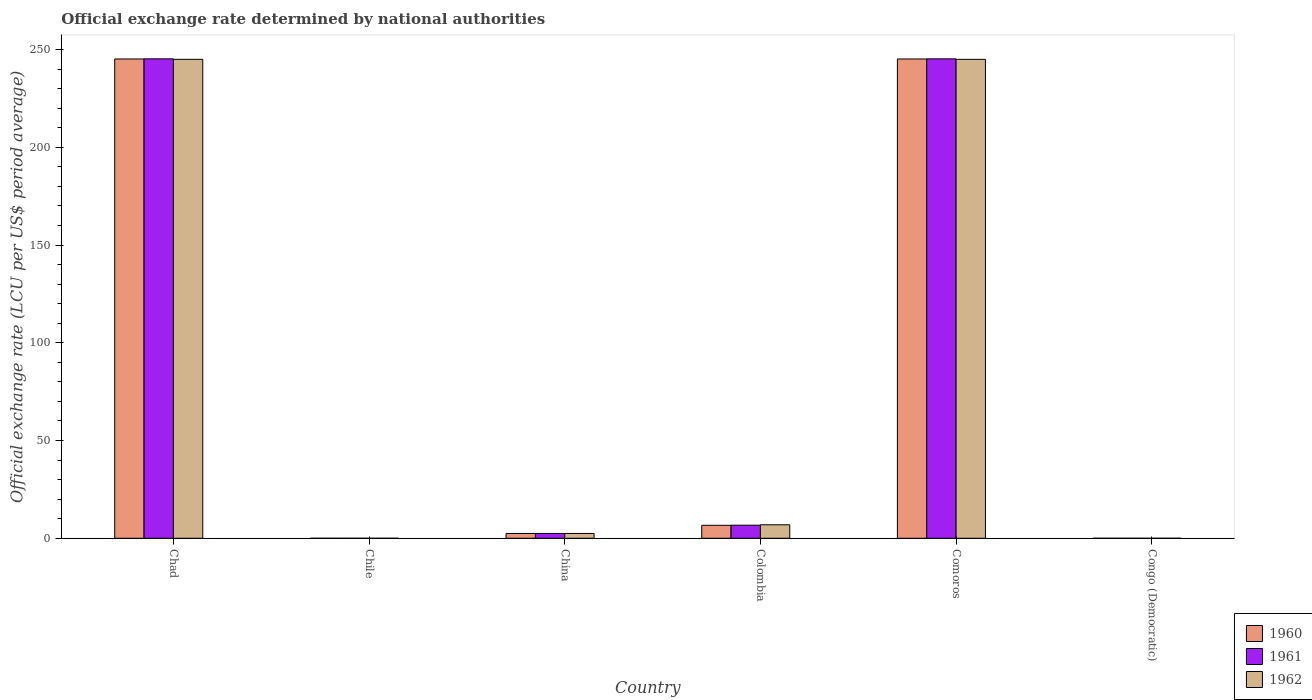How many groups of bars are there?
Your answer should be very brief. 6. Are the number of bars per tick equal to the number of legend labels?
Keep it short and to the point. Yes. What is the official exchange rate in 1961 in Chad?
Ensure brevity in your answer.  245.26. Across all countries, what is the maximum official exchange rate in 1961?
Give a very brief answer. 245.26. Across all countries, what is the minimum official exchange rate in 1961?
Make the answer very short. 1.75e-13. In which country was the official exchange rate in 1961 maximum?
Make the answer very short. Chad. In which country was the official exchange rate in 1961 minimum?
Offer a very short reply. Congo (Democratic). What is the total official exchange rate in 1962 in the graph?
Your answer should be very brief. 499.39. What is the difference between the official exchange rate in 1962 in Chile and that in Colombia?
Your answer should be very brief. -6.9. What is the difference between the official exchange rate in 1962 in China and the official exchange rate in 1961 in Chad?
Provide a succinct answer. -242.8. What is the average official exchange rate in 1962 per country?
Provide a succinct answer. 83.23. What is the difference between the official exchange rate of/in 1960 and official exchange rate of/in 1962 in Chad?
Your answer should be very brief. 0.18. What is the ratio of the official exchange rate in 1960 in Chad to that in China?
Offer a terse response. 99.6. What is the difference between the highest and the second highest official exchange rate in 1960?
Provide a short and direct response. -0. What is the difference between the highest and the lowest official exchange rate in 1961?
Make the answer very short. 245.26. In how many countries, is the official exchange rate in 1961 greater than the average official exchange rate in 1961 taken over all countries?
Ensure brevity in your answer.  2. Is the sum of the official exchange rate in 1961 in Chad and Comoros greater than the maximum official exchange rate in 1960 across all countries?
Your answer should be compact. Yes. What does the 3rd bar from the right in Chad represents?
Provide a short and direct response. 1960. Are all the bars in the graph horizontal?
Provide a short and direct response. No. How many countries are there in the graph?
Your response must be concise. 6. Are the values on the major ticks of Y-axis written in scientific E-notation?
Offer a terse response. No. Does the graph contain grids?
Keep it short and to the point. No. Where does the legend appear in the graph?
Provide a succinct answer. Bottom right. How many legend labels are there?
Ensure brevity in your answer.  3. What is the title of the graph?
Ensure brevity in your answer.  Official exchange rate determined by national authorities. What is the label or title of the X-axis?
Offer a very short reply. Country. What is the label or title of the Y-axis?
Give a very brief answer. Official exchange rate (LCU per US$ period average). What is the Official exchange rate (LCU per US$ period average) in 1960 in Chad?
Ensure brevity in your answer.  245.2. What is the Official exchange rate (LCU per US$ period average) in 1961 in Chad?
Give a very brief answer. 245.26. What is the Official exchange rate (LCU per US$ period average) of 1962 in Chad?
Give a very brief answer. 245.01. What is the Official exchange rate (LCU per US$ period average) in 1960 in Chile?
Your response must be concise. 0. What is the Official exchange rate (LCU per US$ period average) in 1961 in Chile?
Your response must be concise. 0. What is the Official exchange rate (LCU per US$ period average) of 1962 in Chile?
Offer a very short reply. 0. What is the Official exchange rate (LCU per US$ period average) in 1960 in China?
Offer a terse response. 2.46. What is the Official exchange rate (LCU per US$ period average) in 1961 in China?
Offer a terse response. 2.46. What is the Official exchange rate (LCU per US$ period average) in 1962 in China?
Your response must be concise. 2.46. What is the Official exchange rate (LCU per US$ period average) in 1960 in Colombia?
Your response must be concise. 6.63. What is the Official exchange rate (LCU per US$ period average) in 1961 in Colombia?
Ensure brevity in your answer.  6.7. What is the Official exchange rate (LCU per US$ period average) in 1962 in Colombia?
Provide a succinct answer. 6.9. What is the Official exchange rate (LCU per US$ period average) of 1960 in Comoros?
Make the answer very short. 245.19. What is the Official exchange rate (LCU per US$ period average) in 1961 in Comoros?
Your response must be concise. 245.26. What is the Official exchange rate (LCU per US$ period average) of 1962 in Comoros?
Ensure brevity in your answer.  245.01. What is the Official exchange rate (LCU per US$ period average) of 1960 in Congo (Democratic)?
Your response must be concise. 1.7e-13. What is the Official exchange rate (LCU per US$ period average) of 1961 in Congo (Democratic)?
Offer a terse response. 1.75e-13. What is the Official exchange rate (LCU per US$ period average) of 1962 in Congo (Democratic)?
Offer a terse response. 2.1e-13. Across all countries, what is the maximum Official exchange rate (LCU per US$ period average) in 1960?
Keep it short and to the point. 245.2. Across all countries, what is the maximum Official exchange rate (LCU per US$ period average) in 1961?
Offer a terse response. 245.26. Across all countries, what is the maximum Official exchange rate (LCU per US$ period average) in 1962?
Your response must be concise. 245.01. Across all countries, what is the minimum Official exchange rate (LCU per US$ period average) of 1960?
Keep it short and to the point. 1.7e-13. Across all countries, what is the minimum Official exchange rate (LCU per US$ period average) in 1961?
Your response must be concise. 1.75e-13. Across all countries, what is the minimum Official exchange rate (LCU per US$ period average) in 1962?
Your answer should be very brief. 2.1e-13. What is the total Official exchange rate (LCU per US$ period average) in 1960 in the graph?
Your answer should be very brief. 499.49. What is the total Official exchange rate (LCU per US$ period average) of 1961 in the graph?
Your answer should be compact. 499.68. What is the total Official exchange rate (LCU per US$ period average) in 1962 in the graph?
Offer a very short reply. 499.39. What is the difference between the Official exchange rate (LCU per US$ period average) in 1960 in Chad and that in Chile?
Make the answer very short. 245.19. What is the difference between the Official exchange rate (LCU per US$ period average) of 1961 in Chad and that in Chile?
Keep it short and to the point. 245.26. What is the difference between the Official exchange rate (LCU per US$ period average) in 1962 in Chad and that in Chile?
Ensure brevity in your answer.  245.01. What is the difference between the Official exchange rate (LCU per US$ period average) in 1960 in Chad and that in China?
Your response must be concise. 242.73. What is the difference between the Official exchange rate (LCU per US$ period average) in 1961 in Chad and that in China?
Your response must be concise. 242.8. What is the difference between the Official exchange rate (LCU per US$ period average) of 1962 in Chad and that in China?
Your answer should be very brief. 242.55. What is the difference between the Official exchange rate (LCU per US$ period average) in 1960 in Chad and that in Colombia?
Offer a terse response. 238.56. What is the difference between the Official exchange rate (LCU per US$ period average) of 1961 in Chad and that in Colombia?
Your answer should be very brief. 238.56. What is the difference between the Official exchange rate (LCU per US$ period average) of 1962 in Chad and that in Colombia?
Your answer should be very brief. 238.11. What is the difference between the Official exchange rate (LCU per US$ period average) in 1960 in Chad and that in Comoros?
Provide a succinct answer. 0. What is the difference between the Official exchange rate (LCU per US$ period average) of 1961 in Chad and that in Comoros?
Keep it short and to the point. 0. What is the difference between the Official exchange rate (LCU per US$ period average) in 1962 in Chad and that in Comoros?
Your answer should be very brief. 0. What is the difference between the Official exchange rate (LCU per US$ period average) of 1960 in Chad and that in Congo (Democratic)?
Your response must be concise. 245.2. What is the difference between the Official exchange rate (LCU per US$ period average) in 1961 in Chad and that in Congo (Democratic)?
Keep it short and to the point. 245.26. What is the difference between the Official exchange rate (LCU per US$ period average) of 1962 in Chad and that in Congo (Democratic)?
Provide a succinct answer. 245.01. What is the difference between the Official exchange rate (LCU per US$ period average) in 1960 in Chile and that in China?
Make the answer very short. -2.46. What is the difference between the Official exchange rate (LCU per US$ period average) of 1961 in Chile and that in China?
Offer a very short reply. -2.46. What is the difference between the Official exchange rate (LCU per US$ period average) of 1962 in Chile and that in China?
Make the answer very short. -2.46. What is the difference between the Official exchange rate (LCU per US$ period average) of 1960 in Chile and that in Colombia?
Your answer should be very brief. -6.63. What is the difference between the Official exchange rate (LCU per US$ period average) of 1961 in Chile and that in Colombia?
Your response must be concise. -6.7. What is the difference between the Official exchange rate (LCU per US$ period average) of 1962 in Chile and that in Colombia?
Provide a short and direct response. -6.9. What is the difference between the Official exchange rate (LCU per US$ period average) in 1960 in Chile and that in Comoros?
Your response must be concise. -245.19. What is the difference between the Official exchange rate (LCU per US$ period average) in 1961 in Chile and that in Comoros?
Provide a short and direct response. -245.26. What is the difference between the Official exchange rate (LCU per US$ period average) in 1962 in Chile and that in Comoros?
Offer a terse response. -245.01. What is the difference between the Official exchange rate (LCU per US$ period average) of 1960 in Chile and that in Congo (Democratic)?
Offer a very short reply. 0. What is the difference between the Official exchange rate (LCU per US$ period average) of 1961 in Chile and that in Congo (Democratic)?
Provide a short and direct response. 0. What is the difference between the Official exchange rate (LCU per US$ period average) of 1962 in Chile and that in Congo (Democratic)?
Your answer should be compact. 0. What is the difference between the Official exchange rate (LCU per US$ period average) in 1960 in China and that in Colombia?
Provide a succinct answer. -4.17. What is the difference between the Official exchange rate (LCU per US$ period average) in 1961 in China and that in Colombia?
Offer a very short reply. -4.24. What is the difference between the Official exchange rate (LCU per US$ period average) of 1962 in China and that in Colombia?
Your answer should be very brief. -4.44. What is the difference between the Official exchange rate (LCU per US$ period average) of 1960 in China and that in Comoros?
Your answer should be very brief. -242.73. What is the difference between the Official exchange rate (LCU per US$ period average) of 1961 in China and that in Comoros?
Ensure brevity in your answer.  -242.8. What is the difference between the Official exchange rate (LCU per US$ period average) of 1962 in China and that in Comoros?
Offer a very short reply. -242.55. What is the difference between the Official exchange rate (LCU per US$ period average) in 1960 in China and that in Congo (Democratic)?
Offer a terse response. 2.46. What is the difference between the Official exchange rate (LCU per US$ period average) in 1961 in China and that in Congo (Democratic)?
Provide a short and direct response. 2.46. What is the difference between the Official exchange rate (LCU per US$ period average) in 1962 in China and that in Congo (Democratic)?
Your response must be concise. 2.46. What is the difference between the Official exchange rate (LCU per US$ period average) of 1960 in Colombia and that in Comoros?
Give a very brief answer. -238.56. What is the difference between the Official exchange rate (LCU per US$ period average) in 1961 in Colombia and that in Comoros?
Your answer should be compact. -238.56. What is the difference between the Official exchange rate (LCU per US$ period average) of 1962 in Colombia and that in Comoros?
Give a very brief answer. -238.11. What is the difference between the Official exchange rate (LCU per US$ period average) in 1960 in Colombia and that in Congo (Democratic)?
Your response must be concise. 6.63. What is the difference between the Official exchange rate (LCU per US$ period average) in 1962 in Colombia and that in Congo (Democratic)?
Make the answer very short. 6.9. What is the difference between the Official exchange rate (LCU per US$ period average) of 1960 in Comoros and that in Congo (Democratic)?
Offer a very short reply. 245.19. What is the difference between the Official exchange rate (LCU per US$ period average) in 1961 in Comoros and that in Congo (Democratic)?
Your answer should be compact. 245.26. What is the difference between the Official exchange rate (LCU per US$ period average) in 1962 in Comoros and that in Congo (Democratic)?
Offer a terse response. 245.01. What is the difference between the Official exchange rate (LCU per US$ period average) of 1960 in Chad and the Official exchange rate (LCU per US$ period average) of 1961 in Chile?
Offer a terse response. 245.19. What is the difference between the Official exchange rate (LCU per US$ period average) in 1960 in Chad and the Official exchange rate (LCU per US$ period average) in 1962 in Chile?
Your answer should be very brief. 245.19. What is the difference between the Official exchange rate (LCU per US$ period average) of 1961 in Chad and the Official exchange rate (LCU per US$ period average) of 1962 in Chile?
Your answer should be very brief. 245.26. What is the difference between the Official exchange rate (LCU per US$ period average) in 1960 in Chad and the Official exchange rate (LCU per US$ period average) in 1961 in China?
Your response must be concise. 242.73. What is the difference between the Official exchange rate (LCU per US$ period average) of 1960 in Chad and the Official exchange rate (LCU per US$ period average) of 1962 in China?
Ensure brevity in your answer.  242.73. What is the difference between the Official exchange rate (LCU per US$ period average) of 1961 in Chad and the Official exchange rate (LCU per US$ period average) of 1962 in China?
Offer a terse response. 242.8. What is the difference between the Official exchange rate (LCU per US$ period average) in 1960 in Chad and the Official exchange rate (LCU per US$ period average) in 1961 in Colombia?
Make the answer very short. 238.5. What is the difference between the Official exchange rate (LCU per US$ period average) of 1960 in Chad and the Official exchange rate (LCU per US$ period average) of 1962 in Colombia?
Keep it short and to the point. 238.29. What is the difference between the Official exchange rate (LCU per US$ period average) in 1961 in Chad and the Official exchange rate (LCU per US$ period average) in 1962 in Colombia?
Ensure brevity in your answer.  238.36. What is the difference between the Official exchange rate (LCU per US$ period average) in 1960 in Chad and the Official exchange rate (LCU per US$ period average) in 1961 in Comoros?
Provide a succinct answer. -0.06. What is the difference between the Official exchange rate (LCU per US$ period average) of 1960 in Chad and the Official exchange rate (LCU per US$ period average) of 1962 in Comoros?
Make the answer very short. 0.18. What is the difference between the Official exchange rate (LCU per US$ period average) in 1961 in Chad and the Official exchange rate (LCU per US$ period average) in 1962 in Comoros?
Keep it short and to the point. 0.25. What is the difference between the Official exchange rate (LCU per US$ period average) in 1960 in Chad and the Official exchange rate (LCU per US$ period average) in 1961 in Congo (Democratic)?
Your response must be concise. 245.2. What is the difference between the Official exchange rate (LCU per US$ period average) of 1960 in Chad and the Official exchange rate (LCU per US$ period average) of 1962 in Congo (Democratic)?
Provide a short and direct response. 245.2. What is the difference between the Official exchange rate (LCU per US$ period average) of 1961 in Chad and the Official exchange rate (LCU per US$ period average) of 1962 in Congo (Democratic)?
Your answer should be very brief. 245.26. What is the difference between the Official exchange rate (LCU per US$ period average) in 1960 in Chile and the Official exchange rate (LCU per US$ period average) in 1961 in China?
Your answer should be compact. -2.46. What is the difference between the Official exchange rate (LCU per US$ period average) in 1960 in Chile and the Official exchange rate (LCU per US$ period average) in 1962 in China?
Your answer should be compact. -2.46. What is the difference between the Official exchange rate (LCU per US$ period average) of 1961 in Chile and the Official exchange rate (LCU per US$ period average) of 1962 in China?
Offer a terse response. -2.46. What is the difference between the Official exchange rate (LCU per US$ period average) in 1960 in Chile and the Official exchange rate (LCU per US$ period average) in 1961 in Colombia?
Your response must be concise. -6.7. What is the difference between the Official exchange rate (LCU per US$ period average) in 1960 in Chile and the Official exchange rate (LCU per US$ period average) in 1962 in Colombia?
Give a very brief answer. -6.9. What is the difference between the Official exchange rate (LCU per US$ period average) of 1961 in Chile and the Official exchange rate (LCU per US$ period average) of 1962 in Colombia?
Keep it short and to the point. -6.9. What is the difference between the Official exchange rate (LCU per US$ period average) in 1960 in Chile and the Official exchange rate (LCU per US$ period average) in 1961 in Comoros?
Give a very brief answer. -245.26. What is the difference between the Official exchange rate (LCU per US$ period average) in 1960 in Chile and the Official exchange rate (LCU per US$ period average) in 1962 in Comoros?
Your response must be concise. -245.01. What is the difference between the Official exchange rate (LCU per US$ period average) in 1961 in Chile and the Official exchange rate (LCU per US$ period average) in 1962 in Comoros?
Offer a terse response. -245.01. What is the difference between the Official exchange rate (LCU per US$ period average) in 1960 in Chile and the Official exchange rate (LCU per US$ period average) in 1962 in Congo (Democratic)?
Your answer should be very brief. 0. What is the difference between the Official exchange rate (LCU per US$ period average) in 1961 in Chile and the Official exchange rate (LCU per US$ period average) in 1962 in Congo (Democratic)?
Your answer should be very brief. 0. What is the difference between the Official exchange rate (LCU per US$ period average) of 1960 in China and the Official exchange rate (LCU per US$ period average) of 1961 in Colombia?
Offer a very short reply. -4.24. What is the difference between the Official exchange rate (LCU per US$ period average) in 1960 in China and the Official exchange rate (LCU per US$ period average) in 1962 in Colombia?
Keep it short and to the point. -4.44. What is the difference between the Official exchange rate (LCU per US$ period average) of 1961 in China and the Official exchange rate (LCU per US$ period average) of 1962 in Colombia?
Your answer should be compact. -4.44. What is the difference between the Official exchange rate (LCU per US$ period average) in 1960 in China and the Official exchange rate (LCU per US$ period average) in 1961 in Comoros?
Give a very brief answer. -242.8. What is the difference between the Official exchange rate (LCU per US$ period average) in 1960 in China and the Official exchange rate (LCU per US$ period average) in 1962 in Comoros?
Your answer should be very brief. -242.55. What is the difference between the Official exchange rate (LCU per US$ period average) in 1961 in China and the Official exchange rate (LCU per US$ period average) in 1962 in Comoros?
Provide a short and direct response. -242.55. What is the difference between the Official exchange rate (LCU per US$ period average) of 1960 in China and the Official exchange rate (LCU per US$ period average) of 1961 in Congo (Democratic)?
Ensure brevity in your answer.  2.46. What is the difference between the Official exchange rate (LCU per US$ period average) of 1960 in China and the Official exchange rate (LCU per US$ period average) of 1962 in Congo (Democratic)?
Provide a succinct answer. 2.46. What is the difference between the Official exchange rate (LCU per US$ period average) of 1961 in China and the Official exchange rate (LCU per US$ period average) of 1962 in Congo (Democratic)?
Make the answer very short. 2.46. What is the difference between the Official exchange rate (LCU per US$ period average) of 1960 in Colombia and the Official exchange rate (LCU per US$ period average) of 1961 in Comoros?
Ensure brevity in your answer.  -238.62. What is the difference between the Official exchange rate (LCU per US$ period average) in 1960 in Colombia and the Official exchange rate (LCU per US$ period average) in 1962 in Comoros?
Offer a terse response. -238.38. What is the difference between the Official exchange rate (LCU per US$ period average) in 1961 in Colombia and the Official exchange rate (LCU per US$ period average) in 1962 in Comoros?
Ensure brevity in your answer.  -238.31. What is the difference between the Official exchange rate (LCU per US$ period average) in 1960 in Colombia and the Official exchange rate (LCU per US$ period average) in 1961 in Congo (Democratic)?
Offer a very short reply. 6.63. What is the difference between the Official exchange rate (LCU per US$ period average) of 1960 in Colombia and the Official exchange rate (LCU per US$ period average) of 1962 in Congo (Democratic)?
Give a very brief answer. 6.63. What is the difference between the Official exchange rate (LCU per US$ period average) in 1961 in Colombia and the Official exchange rate (LCU per US$ period average) in 1962 in Congo (Democratic)?
Your answer should be very brief. 6.7. What is the difference between the Official exchange rate (LCU per US$ period average) in 1960 in Comoros and the Official exchange rate (LCU per US$ period average) in 1961 in Congo (Democratic)?
Your answer should be very brief. 245.19. What is the difference between the Official exchange rate (LCU per US$ period average) of 1960 in Comoros and the Official exchange rate (LCU per US$ period average) of 1962 in Congo (Democratic)?
Provide a succinct answer. 245.19. What is the difference between the Official exchange rate (LCU per US$ period average) in 1961 in Comoros and the Official exchange rate (LCU per US$ period average) in 1962 in Congo (Democratic)?
Offer a very short reply. 245.26. What is the average Official exchange rate (LCU per US$ period average) in 1960 per country?
Your response must be concise. 83.25. What is the average Official exchange rate (LCU per US$ period average) of 1961 per country?
Provide a short and direct response. 83.28. What is the average Official exchange rate (LCU per US$ period average) of 1962 per country?
Offer a terse response. 83.23. What is the difference between the Official exchange rate (LCU per US$ period average) of 1960 and Official exchange rate (LCU per US$ period average) of 1961 in Chad?
Give a very brief answer. -0.07. What is the difference between the Official exchange rate (LCU per US$ period average) of 1960 and Official exchange rate (LCU per US$ period average) of 1962 in Chad?
Give a very brief answer. 0.18. What is the difference between the Official exchange rate (LCU per US$ period average) of 1961 and Official exchange rate (LCU per US$ period average) of 1962 in Chad?
Your response must be concise. 0.25. What is the difference between the Official exchange rate (LCU per US$ period average) of 1960 and Official exchange rate (LCU per US$ period average) of 1961 in Chile?
Make the answer very short. -0. What is the difference between the Official exchange rate (LCU per US$ period average) in 1960 and Official exchange rate (LCU per US$ period average) in 1962 in China?
Keep it short and to the point. 0. What is the difference between the Official exchange rate (LCU per US$ period average) in 1960 and Official exchange rate (LCU per US$ period average) in 1961 in Colombia?
Ensure brevity in your answer.  -0.07. What is the difference between the Official exchange rate (LCU per US$ period average) in 1960 and Official exchange rate (LCU per US$ period average) in 1962 in Colombia?
Your response must be concise. -0.27. What is the difference between the Official exchange rate (LCU per US$ period average) in 1961 and Official exchange rate (LCU per US$ period average) in 1962 in Colombia?
Your answer should be compact. -0.2. What is the difference between the Official exchange rate (LCU per US$ period average) in 1960 and Official exchange rate (LCU per US$ period average) in 1961 in Comoros?
Your response must be concise. -0.07. What is the difference between the Official exchange rate (LCU per US$ period average) of 1960 and Official exchange rate (LCU per US$ period average) of 1962 in Comoros?
Offer a terse response. 0.18. What is the difference between the Official exchange rate (LCU per US$ period average) in 1961 and Official exchange rate (LCU per US$ period average) in 1962 in Comoros?
Your response must be concise. 0.25. What is the difference between the Official exchange rate (LCU per US$ period average) in 1960 and Official exchange rate (LCU per US$ period average) in 1961 in Congo (Democratic)?
Offer a very short reply. -0. What is the difference between the Official exchange rate (LCU per US$ period average) of 1960 and Official exchange rate (LCU per US$ period average) of 1962 in Congo (Democratic)?
Provide a short and direct response. -0. What is the difference between the Official exchange rate (LCU per US$ period average) of 1961 and Official exchange rate (LCU per US$ period average) of 1962 in Congo (Democratic)?
Provide a short and direct response. -0. What is the ratio of the Official exchange rate (LCU per US$ period average) of 1960 in Chad to that in Chile?
Your response must be concise. 2.34e+05. What is the ratio of the Official exchange rate (LCU per US$ period average) of 1961 in Chad to that in Chile?
Your answer should be very brief. 2.34e+05. What is the ratio of the Official exchange rate (LCU per US$ period average) in 1962 in Chad to that in Chile?
Offer a very short reply. 2.32e+05. What is the ratio of the Official exchange rate (LCU per US$ period average) of 1960 in Chad to that in China?
Ensure brevity in your answer.  99.6. What is the ratio of the Official exchange rate (LCU per US$ period average) of 1961 in Chad to that in China?
Offer a very short reply. 99.63. What is the ratio of the Official exchange rate (LCU per US$ period average) in 1962 in Chad to that in China?
Ensure brevity in your answer.  99.53. What is the ratio of the Official exchange rate (LCU per US$ period average) in 1960 in Chad to that in Colombia?
Offer a very short reply. 36.95. What is the ratio of the Official exchange rate (LCU per US$ period average) in 1961 in Chad to that in Colombia?
Provide a short and direct response. 36.61. What is the ratio of the Official exchange rate (LCU per US$ period average) in 1962 in Chad to that in Colombia?
Offer a very short reply. 35.5. What is the ratio of the Official exchange rate (LCU per US$ period average) of 1962 in Chad to that in Comoros?
Provide a short and direct response. 1. What is the ratio of the Official exchange rate (LCU per US$ period average) in 1960 in Chad to that in Congo (Democratic)?
Give a very brief answer. 1.44e+15. What is the ratio of the Official exchange rate (LCU per US$ period average) of 1961 in Chad to that in Congo (Democratic)?
Give a very brief answer. 1.40e+15. What is the ratio of the Official exchange rate (LCU per US$ period average) in 1962 in Chad to that in Congo (Democratic)?
Ensure brevity in your answer.  1.17e+15. What is the ratio of the Official exchange rate (LCU per US$ period average) in 1960 in Chile to that in China?
Offer a very short reply. 0. What is the ratio of the Official exchange rate (LCU per US$ period average) in 1961 in Chile to that in China?
Provide a short and direct response. 0. What is the ratio of the Official exchange rate (LCU per US$ period average) of 1960 in Chile to that in Colombia?
Make the answer very short. 0. What is the ratio of the Official exchange rate (LCU per US$ period average) in 1961 in Chile to that in Colombia?
Your answer should be very brief. 0. What is the ratio of the Official exchange rate (LCU per US$ period average) of 1962 in Chile to that in Colombia?
Offer a very short reply. 0. What is the ratio of the Official exchange rate (LCU per US$ period average) of 1960 in Chile to that in Comoros?
Offer a terse response. 0. What is the ratio of the Official exchange rate (LCU per US$ period average) in 1961 in Chile to that in Comoros?
Give a very brief answer. 0. What is the ratio of the Official exchange rate (LCU per US$ period average) of 1962 in Chile to that in Comoros?
Ensure brevity in your answer.  0. What is the ratio of the Official exchange rate (LCU per US$ period average) of 1960 in Chile to that in Congo (Democratic)?
Make the answer very short. 6.17e+09. What is the ratio of the Official exchange rate (LCU per US$ period average) of 1961 in Chile to that in Congo (Democratic)?
Your answer should be very brief. 6.00e+09. What is the ratio of the Official exchange rate (LCU per US$ period average) of 1962 in Chile to that in Congo (Democratic)?
Give a very brief answer. 5.04e+09. What is the ratio of the Official exchange rate (LCU per US$ period average) in 1960 in China to that in Colombia?
Offer a terse response. 0.37. What is the ratio of the Official exchange rate (LCU per US$ period average) in 1961 in China to that in Colombia?
Offer a terse response. 0.37. What is the ratio of the Official exchange rate (LCU per US$ period average) of 1962 in China to that in Colombia?
Provide a succinct answer. 0.36. What is the ratio of the Official exchange rate (LCU per US$ period average) of 1960 in China to that in Comoros?
Give a very brief answer. 0.01. What is the ratio of the Official exchange rate (LCU per US$ period average) in 1961 in China to that in Comoros?
Your response must be concise. 0.01. What is the ratio of the Official exchange rate (LCU per US$ period average) of 1960 in China to that in Congo (Democratic)?
Your answer should be very brief. 1.45e+13. What is the ratio of the Official exchange rate (LCU per US$ period average) in 1961 in China to that in Congo (Democratic)?
Make the answer very short. 1.41e+13. What is the ratio of the Official exchange rate (LCU per US$ period average) of 1962 in China to that in Congo (Democratic)?
Provide a short and direct response. 1.17e+13. What is the ratio of the Official exchange rate (LCU per US$ period average) of 1960 in Colombia to that in Comoros?
Your answer should be very brief. 0.03. What is the ratio of the Official exchange rate (LCU per US$ period average) in 1961 in Colombia to that in Comoros?
Offer a terse response. 0.03. What is the ratio of the Official exchange rate (LCU per US$ period average) in 1962 in Colombia to that in Comoros?
Your answer should be compact. 0.03. What is the ratio of the Official exchange rate (LCU per US$ period average) in 1960 in Colombia to that in Congo (Democratic)?
Provide a succinct answer. 3.90e+13. What is the ratio of the Official exchange rate (LCU per US$ period average) of 1961 in Colombia to that in Congo (Democratic)?
Ensure brevity in your answer.  3.83e+13. What is the ratio of the Official exchange rate (LCU per US$ period average) in 1962 in Colombia to that in Congo (Democratic)?
Offer a very short reply. 3.29e+13. What is the ratio of the Official exchange rate (LCU per US$ period average) of 1960 in Comoros to that in Congo (Democratic)?
Your answer should be very brief. 1.44e+15. What is the ratio of the Official exchange rate (LCU per US$ period average) of 1961 in Comoros to that in Congo (Democratic)?
Your response must be concise. 1.40e+15. What is the ratio of the Official exchange rate (LCU per US$ period average) in 1962 in Comoros to that in Congo (Democratic)?
Offer a terse response. 1.17e+15. What is the difference between the highest and the second highest Official exchange rate (LCU per US$ period average) of 1960?
Your answer should be very brief. 0. What is the difference between the highest and the second highest Official exchange rate (LCU per US$ period average) of 1961?
Your answer should be very brief. 0. What is the difference between the highest and the second highest Official exchange rate (LCU per US$ period average) of 1962?
Offer a terse response. 0. What is the difference between the highest and the lowest Official exchange rate (LCU per US$ period average) of 1960?
Offer a terse response. 245.2. What is the difference between the highest and the lowest Official exchange rate (LCU per US$ period average) of 1961?
Your response must be concise. 245.26. What is the difference between the highest and the lowest Official exchange rate (LCU per US$ period average) of 1962?
Give a very brief answer. 245.01. 